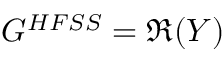<formula> <loc_0><loc_0><loc_500><loc_500>G ^ { H F S S } = \Re ( Y )</formula> 